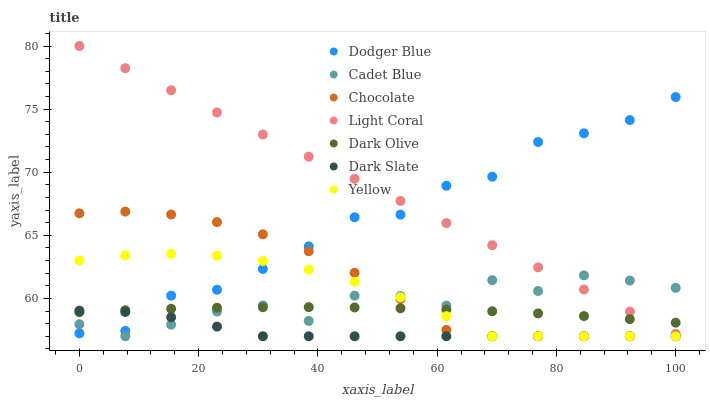Does Dark Slate have the minimum area under the curve?
Answer yes or no. Yes. Does Light Coral have the maximum area under the curve?
Answer yes or no. Yes. Does Dark Olive have the minimum area under the curve?
Answer yes or no. No. Does Dark Olive have the maximum area under the curve?
Answer yes or no. No. Is Light Coral the smoothest?
Answer yes or no. Yes. Is Cadet Blue the roughest?
Answer yes or no. Yes. Is Dark Olive the smoothest?
Answer yes or no. No. Is Dark Olive the roughest?
Answer yes or no. No. Does Cadet Blue have the lowest value?
Answer yes or no. Yes. Does Dark Olive have the lowest value?
Answer yes or no. No. Does Light Coral have the highest value?
Answer yes or no. Yes. Does Dark Olive have the highest value?
Answer yes or no. No. Is Yellow less than Light Coral?
Answer yes or no. Yes. Is Light Coral greater than Chocolate?
Answer yes or no. Yes. Does Dodger Blue intersect Dark Slate?
Answer yes or no. Yes. Is Dodger Blue less than Dark Slate?
Answer yes or no. No. Is Dodger Blue greater than Dark Slate?
Answer yes or no. No. Does Yellow intersect Light Coral?
Answer yes or no. No. 